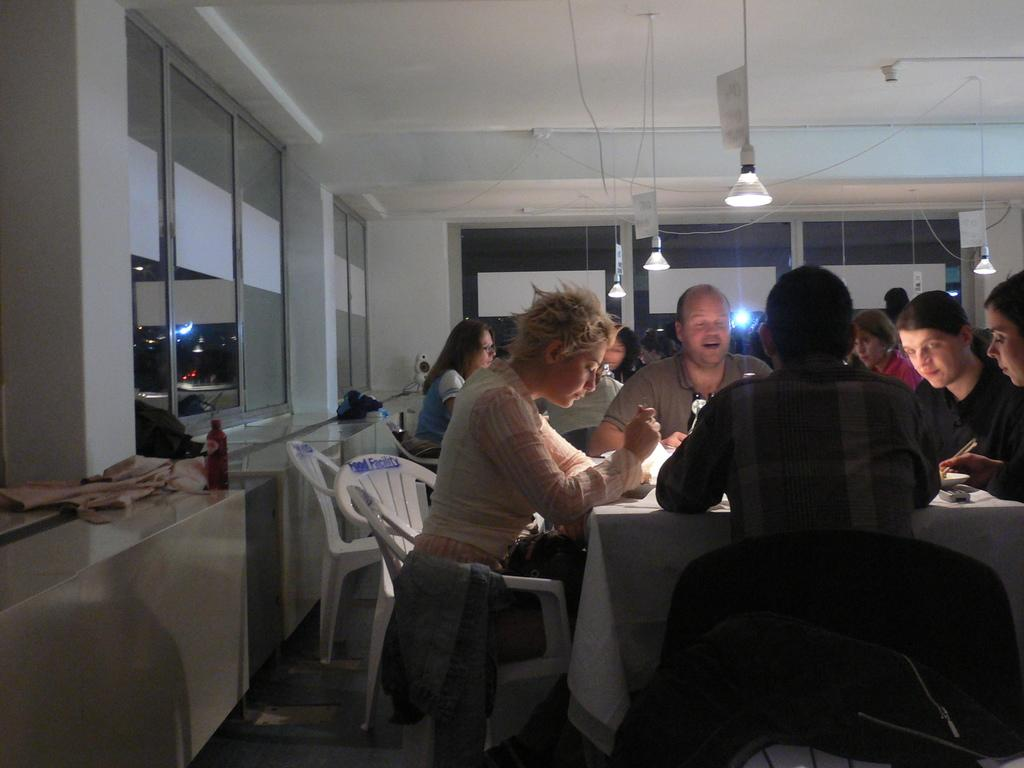How many people are in the image? There is a group of people in the image, but the exact number is not specified. What are the people doing in the image? The people are sitting around a table in the image. What are the people sitting on? The people are sitting on chairs in the image. What is in the middle of the table? There is a light in the middle of the table in the image. What is on the left side of the image? There is a glass wall on the left side of the image. What type of record can be seen playing on the turntable in the image? There is no turntable or record present in the image. What time of day is it in the image? The time of day is not specified in the image. 